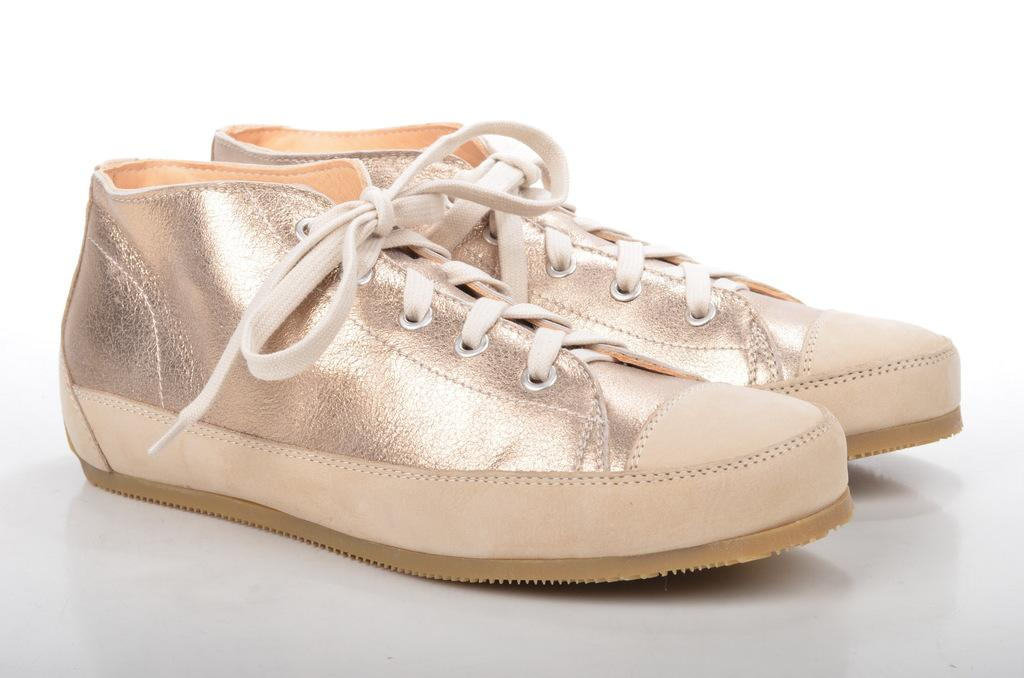What is placed on the floor in the image? There is a pair of shoes on the floor. How many baby goats can be seen playing with the shoes in the image? There are no baby goats present in the image; it only features a pair of shoes placed on the floor. How many kittens can be seen sleeping next to the shoes in the image? There are no kittens present in the image; it only features a pair of shoes placed on the floor. 